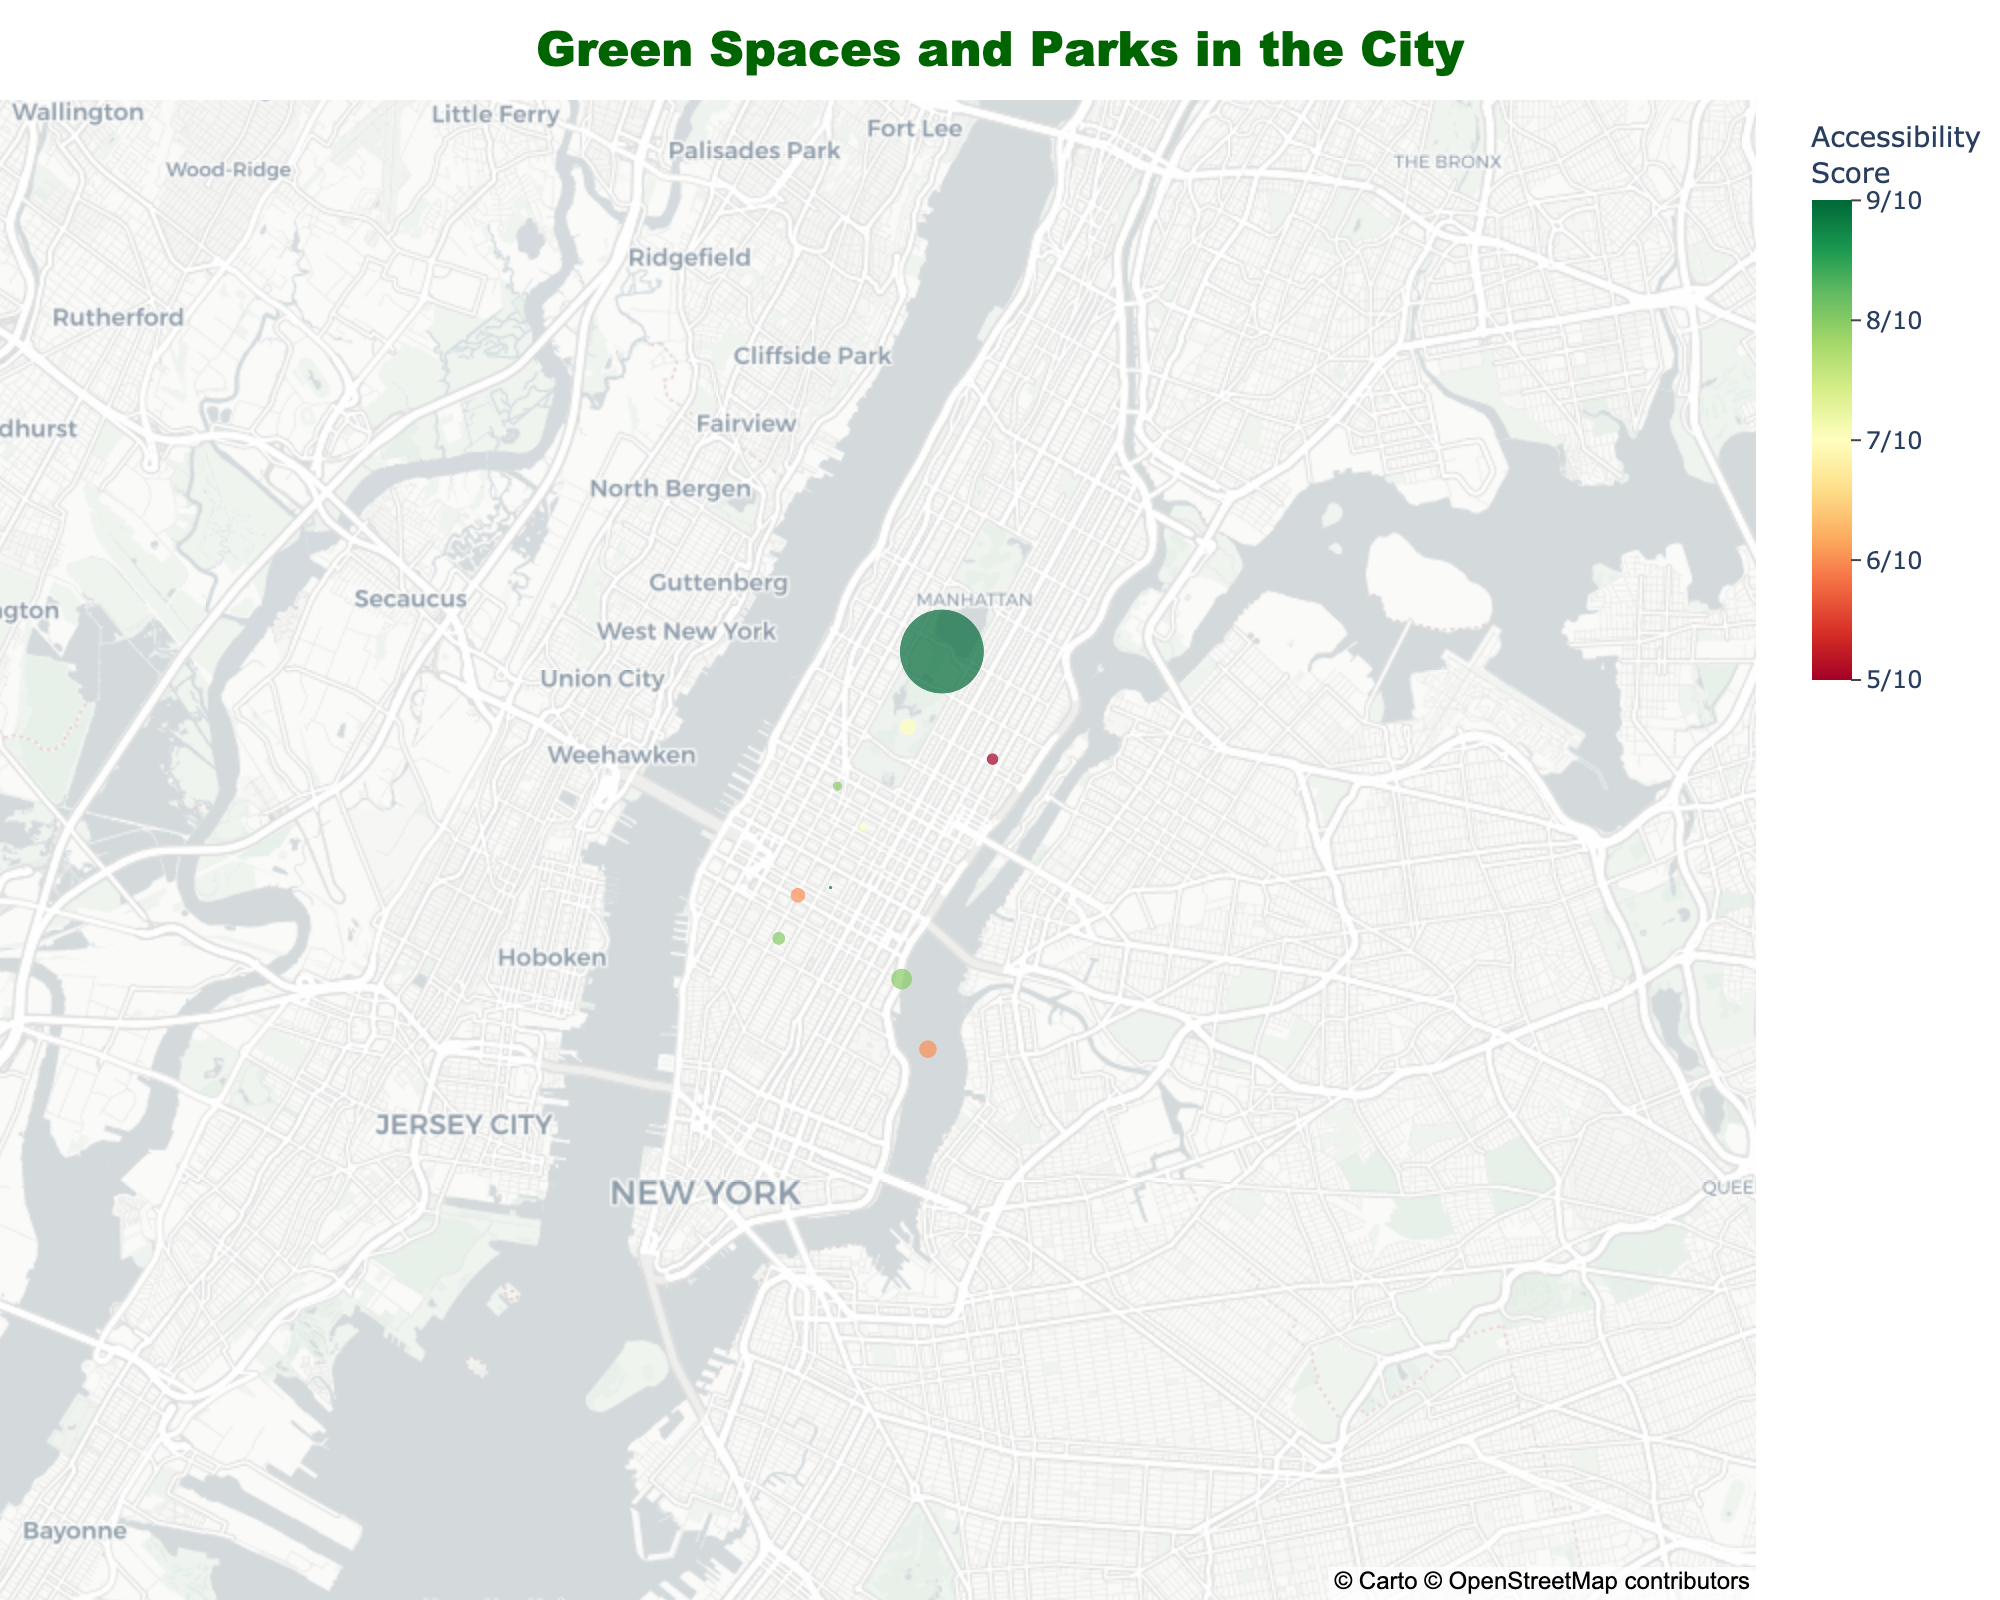What is the title of the figure? To find the title, look at the top center of the figure where the text is displayed prominently.
Answer: Green Spaces and Parks in the City How many parks are shown on the map? Count all the data points representing different parks.
Answer: 10 Which park has the highest accessibility score? Look through the color coding in the figure and find the park with the highest value on the color scale.
Answer: Central Park and Elm Street Pocket Park What is the area of Riverside Gardens in acres? Hover over the data point for Riverside Gardens to see its detailed information, including the area.
Answer: 35 acres Which park has the smallest area? Compare the sizes of all the data points on the map and identify the smallest one.
Answer: Elm Street Pocket Park How many parks have an accessibility score of 8 or higher? Count the number of parks where the color scale indicates an accessibility score of 8 or above.
Answer: 5 What are the features available in Green Meadows? Hover over Green Meadows to see the detailed information, including the list of features.
Answer: Soccer fields; Playground; Pond Which park is closest to the latitude 40.75 and longitude -73.98? Look at the geographic location of all the parks and identify the one closest to the given latitude and longitude.
Answer: Maple Grove What is the average accessibility score of all the parks? Add up the accessibility scores of all the parks and divide by the number of parks: (9 + 7 + 8 + 6 + 8 + 5 + 7 + 9 + 8 + 6) / 10
Answer: 7.3 Which two parks are closest to each other geographically? Visually inspect the proximity of data points on the map.
Answer: Central Park and Riverside Gardens 